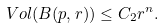<formula> <loc_0><loc_0><loc_500><loc_500>V o l ( B ( p , r ) ) \leq C _ { 2 } r ^ { n } .</formula> 